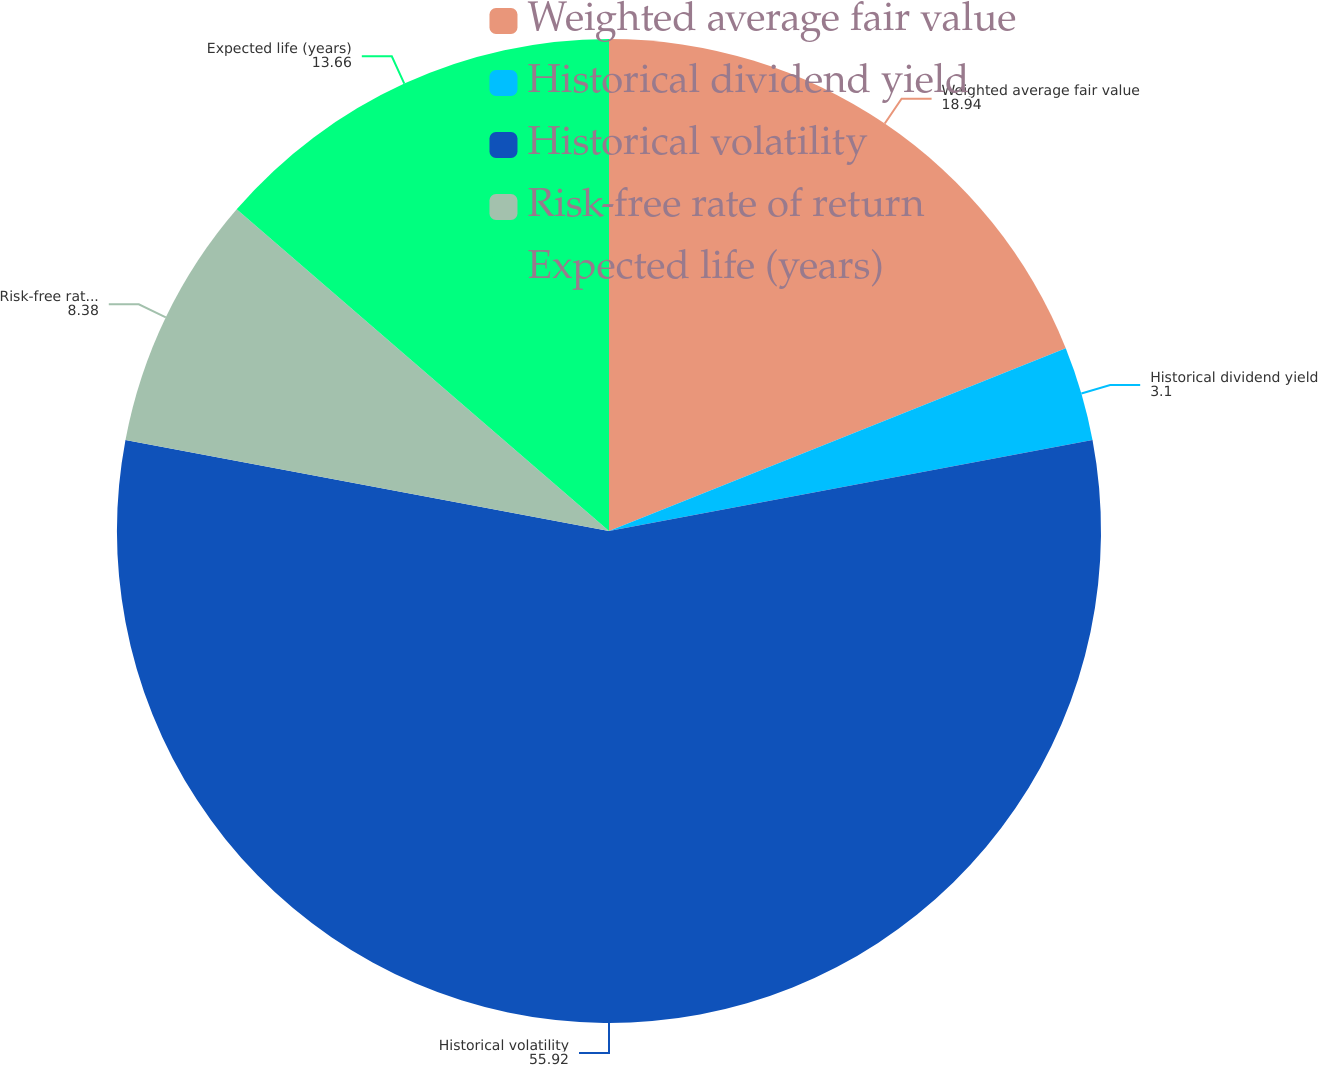Convert chart to OTSL. <chart><loc_0><loc_0><loc_500><loc_500><pie_chart><fcel>Weighted average fair value<fcel>Historical dividend yield<fcel>Historical volatility<fcel>Risk-free rate of return<fcel>Expected life (years)<nl><fcel>18.94%<fcel>3.1%<fcel>55.92%<fcel>8.38%<fcel>13.66%<nl></chart> 